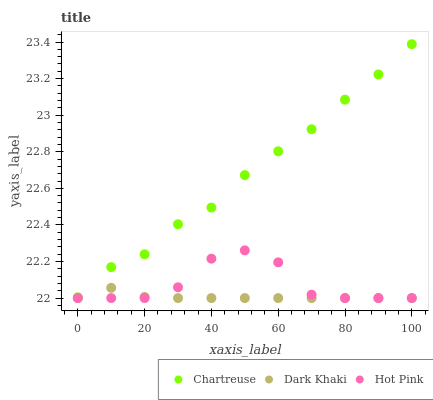Does Dark Khaki have the minimum area under the curve?
Answer yes or no. Yes. Does Chartreuse have the maximum area under the curve?
Answer yes or no. Yes. Does Hot Pink have the minimum area under the curve?
Answer yes or no. No. Does Hot Pink have the maximum area under the curve?
Answer yes or no. No. Is Dark Khaki the smoothest?
Answer yes or no. Yes. Is Hot Pink the roughest?
Answer yes or no. Yes. Is Chartreuse the smoothest?
Answer yes or no. No. Is Chartreuse the roughest?
Answer yes or no. No. Does Dark Khaki have the lowest value?
Answer yes or no. Yes. Does Chartreuse have the lowest value?
Answer yes or no. No. Does Chartreuse have the highest value?
Answer yes or no. Yes. Does Hot Pink have the highest value?
Answer yes or no. No. Is Hot Pink less than Chartreuse?
Answer yes or no. Yes. Is Chartreuse greater than Dark Khaki?
Answer yes or no. Yes. Does Hot Pink intersect Dark Khaki?
Answer yes or no. Yes. Is Hot Pink less than Dark Khaki?
Answer yes or no. No. Is Hot Pink greater than Dark Khaki?
Answer yes or no. No. Does Hot Pink intersect Chartreuse?
Answer yes or no. No. 